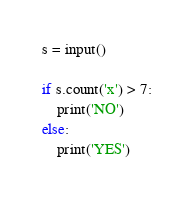Convert code to text. <code><loc_0><loc_0><loc_500><loc_500><_Python_>s = input()

if s.count('x') > 7:
    print('NO')
else:
    print('YES')</code> 